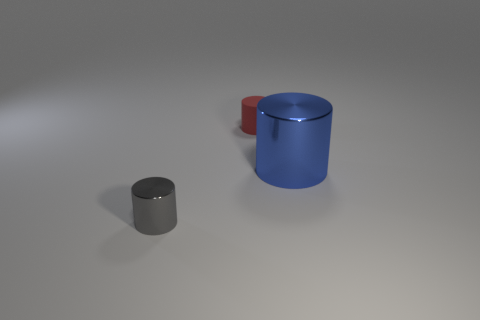Add 3 large yellow spheres. How many objects exist? 6 Add 1 red rubber cylinders. How many red rubber cylinders are left? 2 Add 3 large blue objects. How many large blue objects exist? 4 Subtract 0 yellow balls. How many objects are left? 3 Subtract all small matte objects. Subtract all metallic cylinders. How many objects are left? 0 